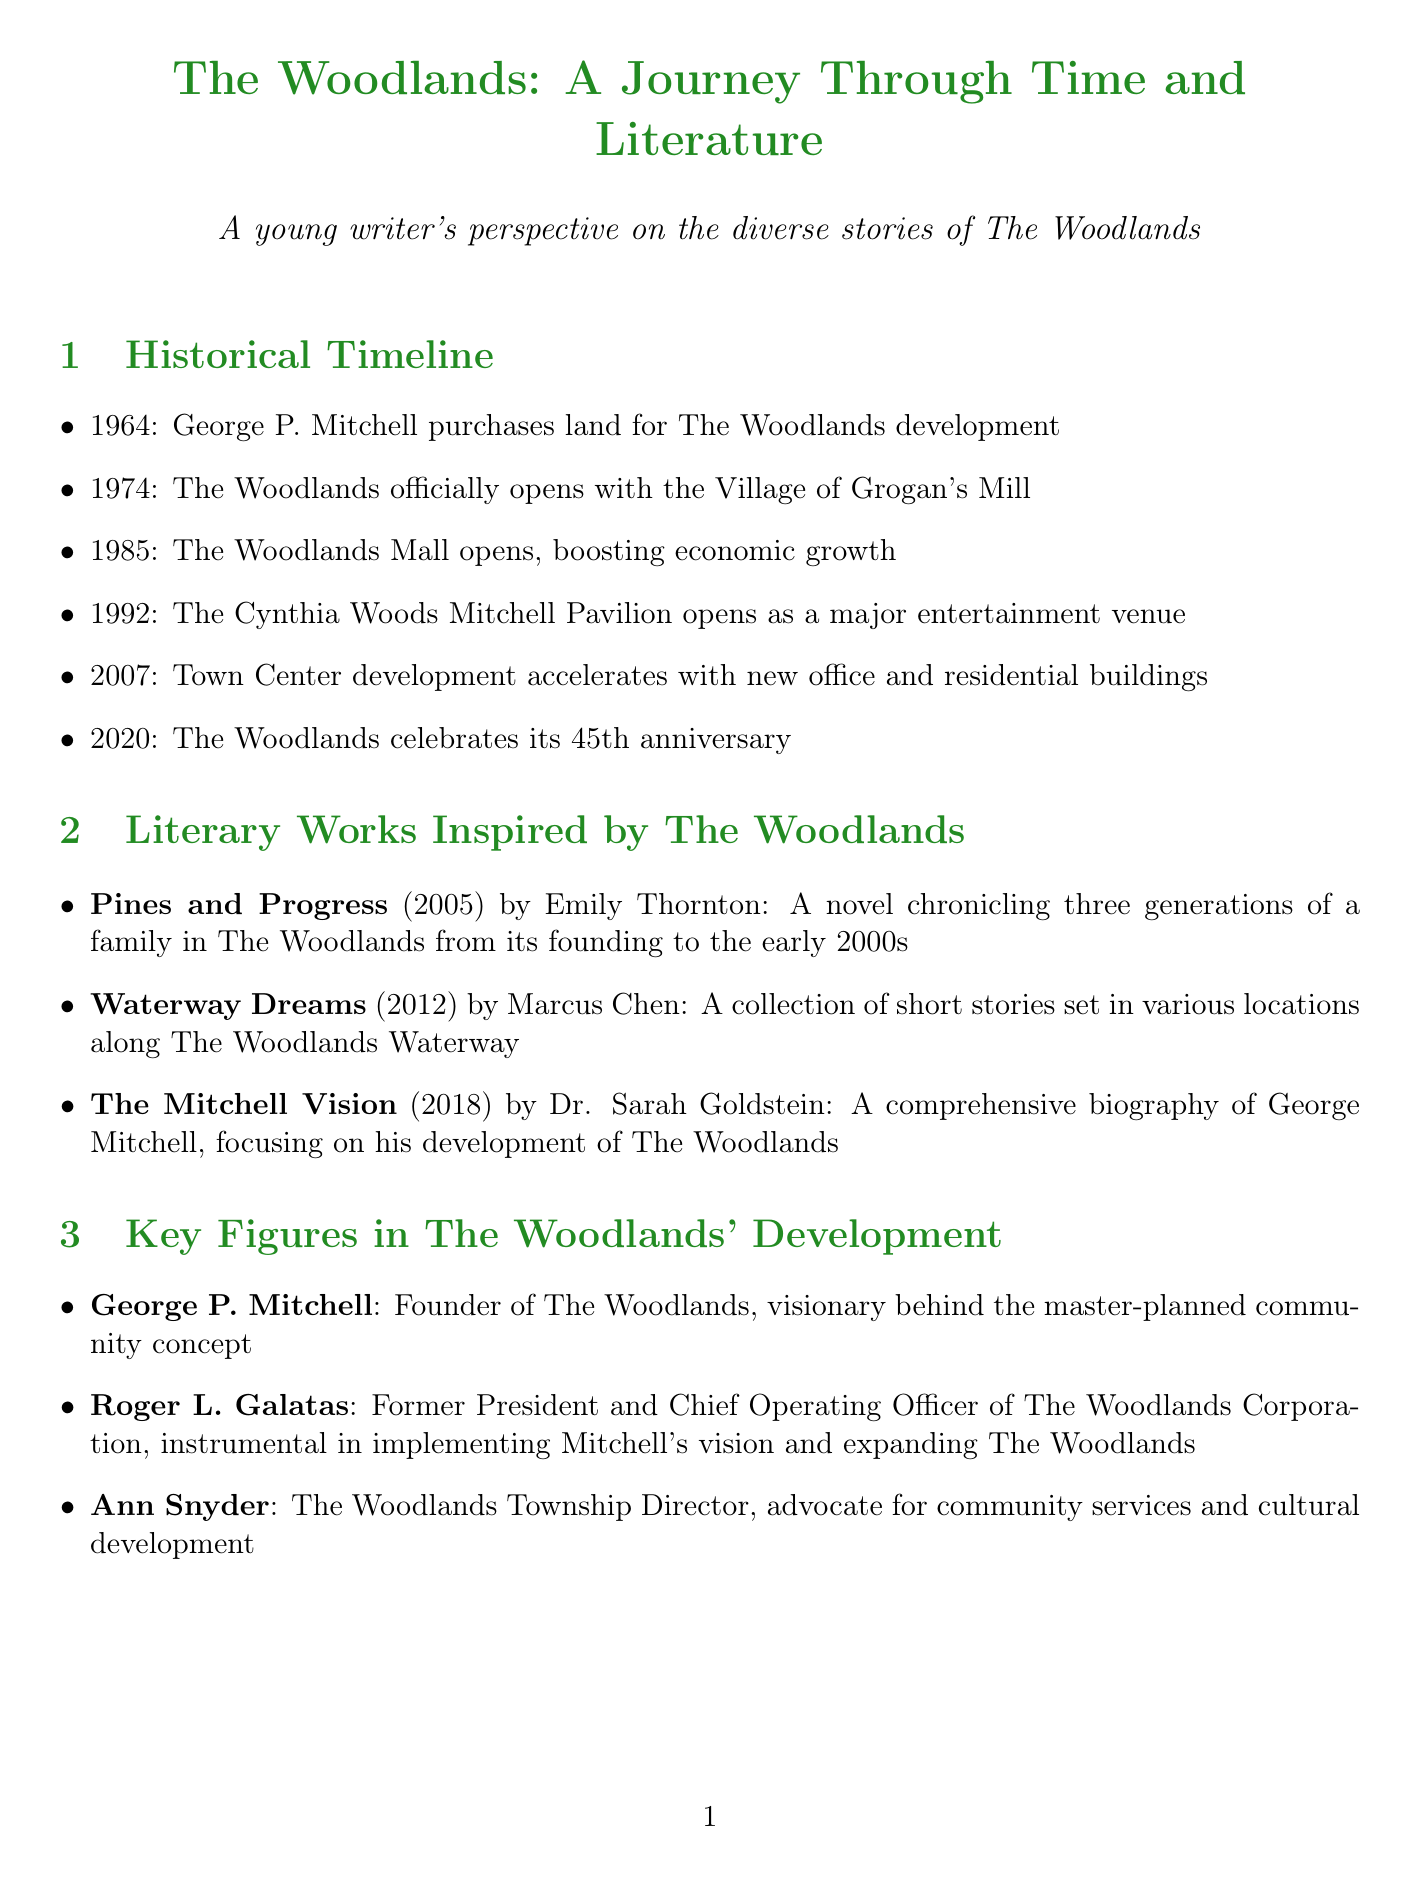What year did the Woodlands officially open? The document states that The Woodlands officially opens in 1974.
Answer: 1974 Who is the author of "Pines and Progress"? The author of "Pines and Progress" is Emily Thornton.
Answer: Emily Thornton What environmental initiative was established in 2007? The document lists the George Mitchell Nature Preserve as being established in 2007.
Answer: George Mitchell Nature Preserve What major event occurred in 2016 that boosted the economy of The Woodlands? The opening of the ExxonMobil campus in 2016 is noted as a key economic milestone in the document.
Answer: ExxonMobil campus opens Which cultural institution was founded in 2010? The document mentions The Woodlands Children's Museum as being founded in 2010.
Answer: The Woodlands Children's Museum What is the significance of George P. Mitchell in The Woodlands? George P. Mitchell is identified as the founder and visionary behind the master-planned community concept in the document.
Answer: Founder What year did The Woodlands celebrate its 45th anniversary? The document indicates that The Woodlands celebrated its 45th anniversary in 2020.
Answer: 2020 Which literary work focuses on the biography of George Mitchell? The document mentions "The Mitchell Vision" by Dr. Sarah Goldstein as the biography focusing on George Mitchell.
Answer: The Mitchell Vision 